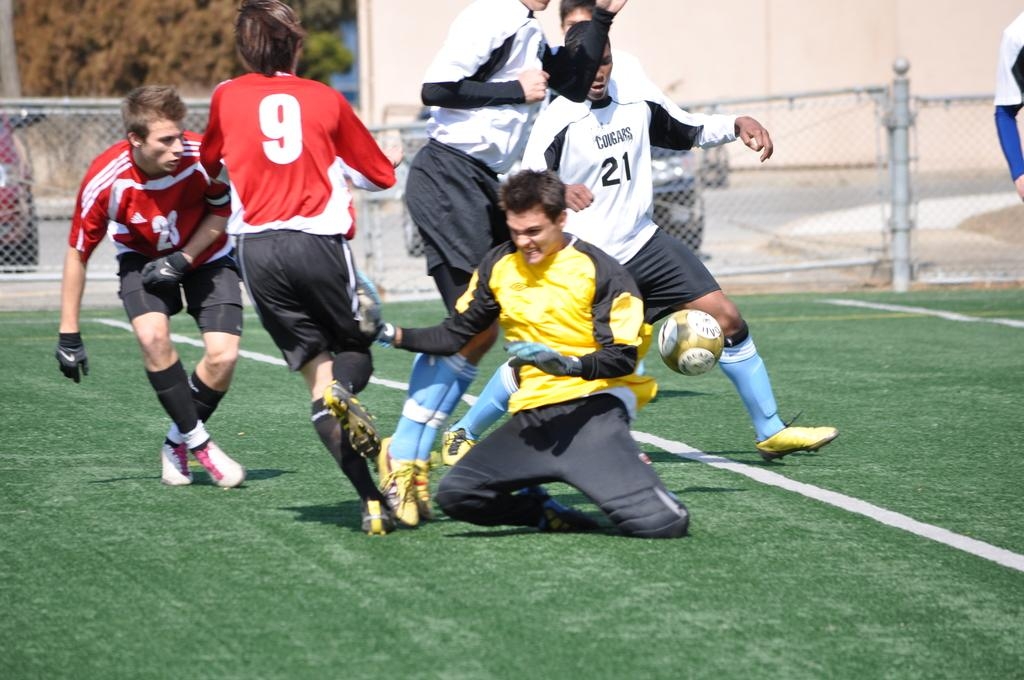<image>
Describe the image concisely. Cougars logo on a jersey with the number twenty one on the front 